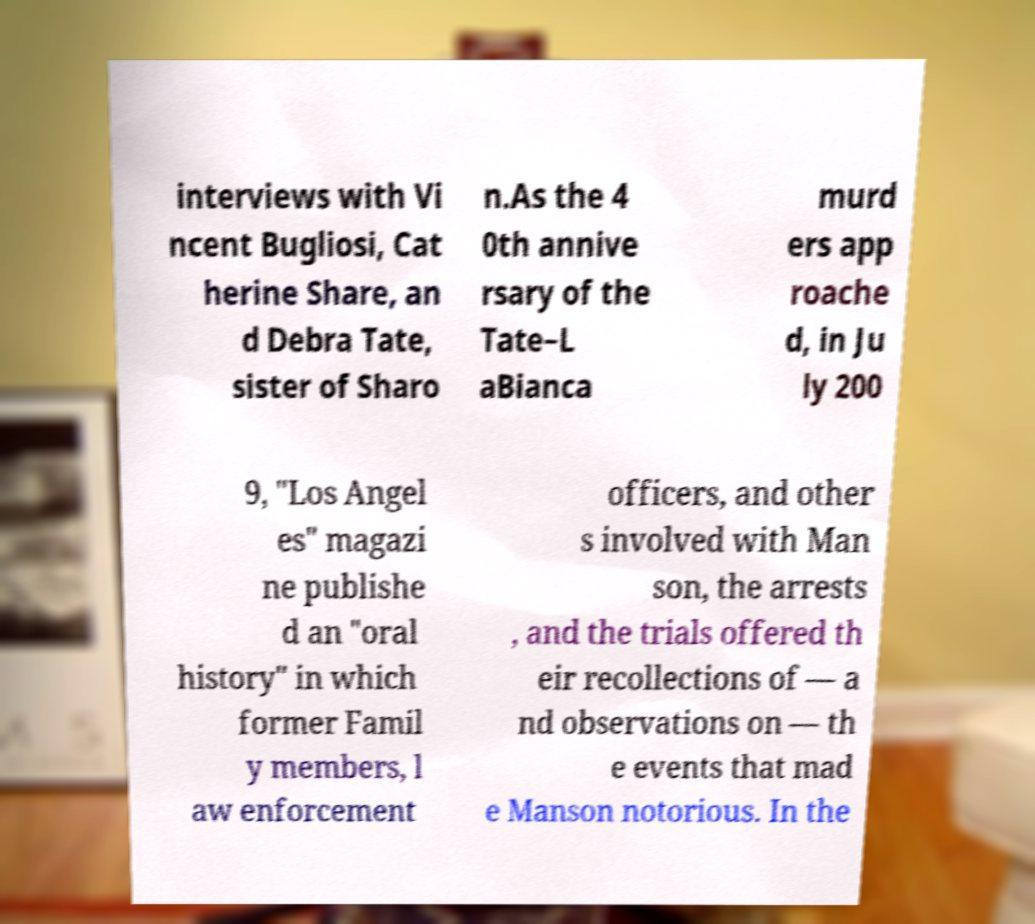Please read and relay the text visible in this image. What does it say? interviews with Vi ncent Bugliosi, Cat herine Share, an d Debra Tate, sister of Sharo n.As the 4 0th annive rsary of the Tate–L aBianca murd ers app roache d, in Ju ly 200 9, "Los Angel es" magazi ne publishe d an "oral history" in which former Famil y members, l aw enforcement officers, and other s involved with Man son, the arrests , and the trials offered th eir recollections of — a nd observations on — th e events that mad e Manson notorious. In the 